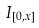Convert formula to latex. <formula><loc_0><loc_0><loc_500><loc_500>I _ { [ 0 , x ] }</formula> 